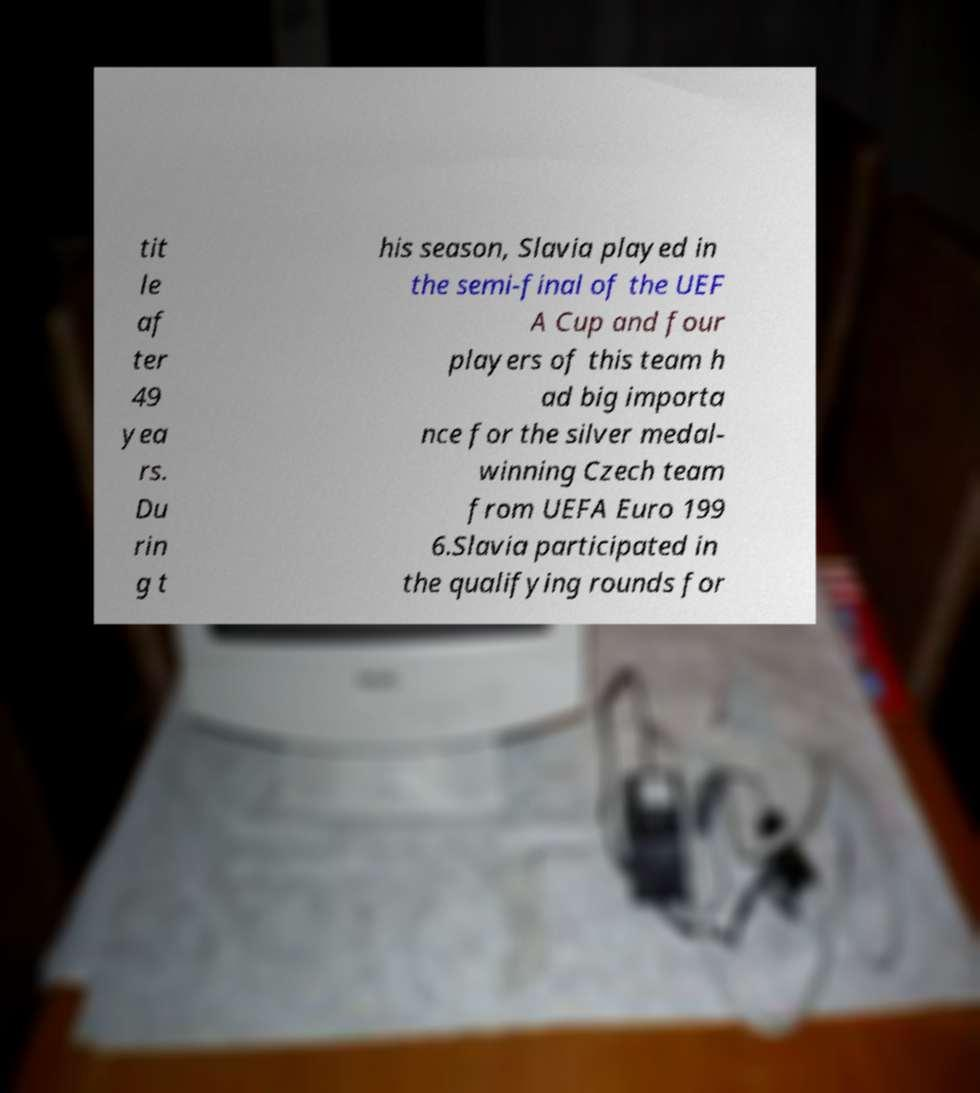Can you accurately transcribe the text from the provided image for me? tit le af ter 49 yea rs. Du rin g t his season, Slavia played in the semi-final of the UEF A Cup and four players of this team h ad big importa nce for the silver medal- winning Czech team from UEFA Euro 199 6.Slavia participated in the qualifying rounds for 